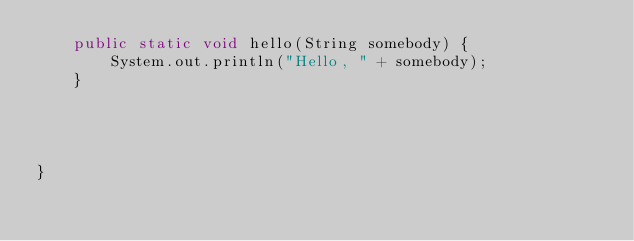<code> <loc_0><loc_0><loc_500><loc_500><_Java_>    public static void hello(String somebody) {
        System.out.println("Hello, " + somebody);
    }




}</code> 